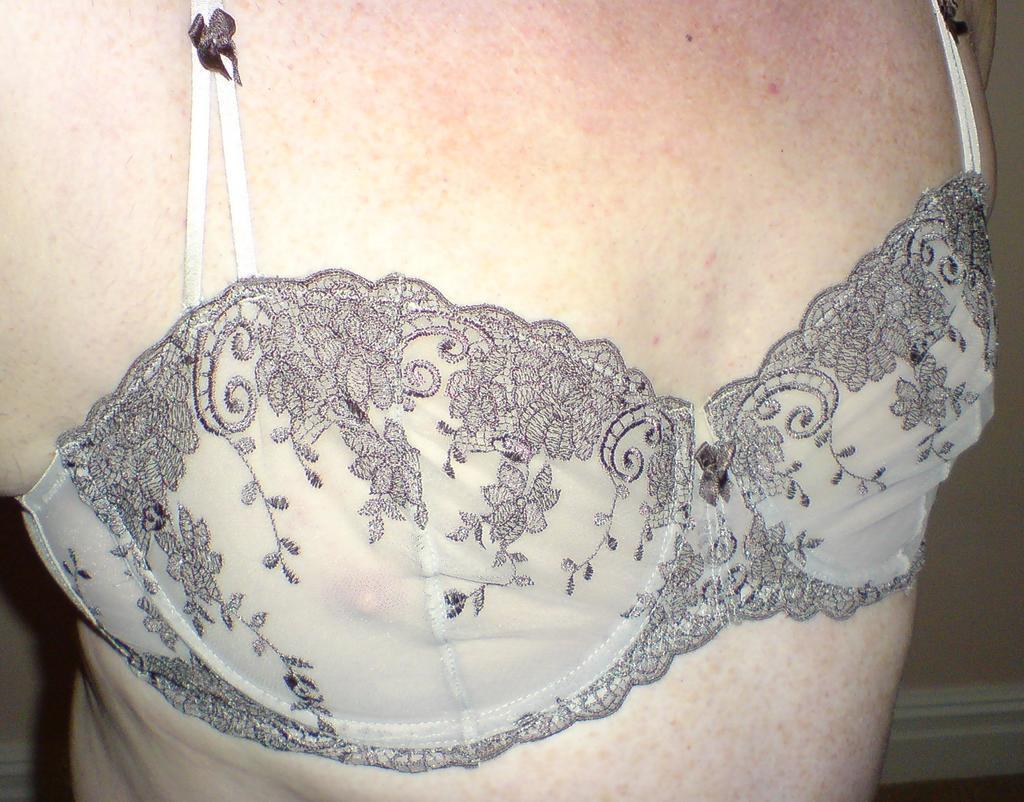In one or two sentences, can you explain what this image depicts? In this image I can see a person's body. 